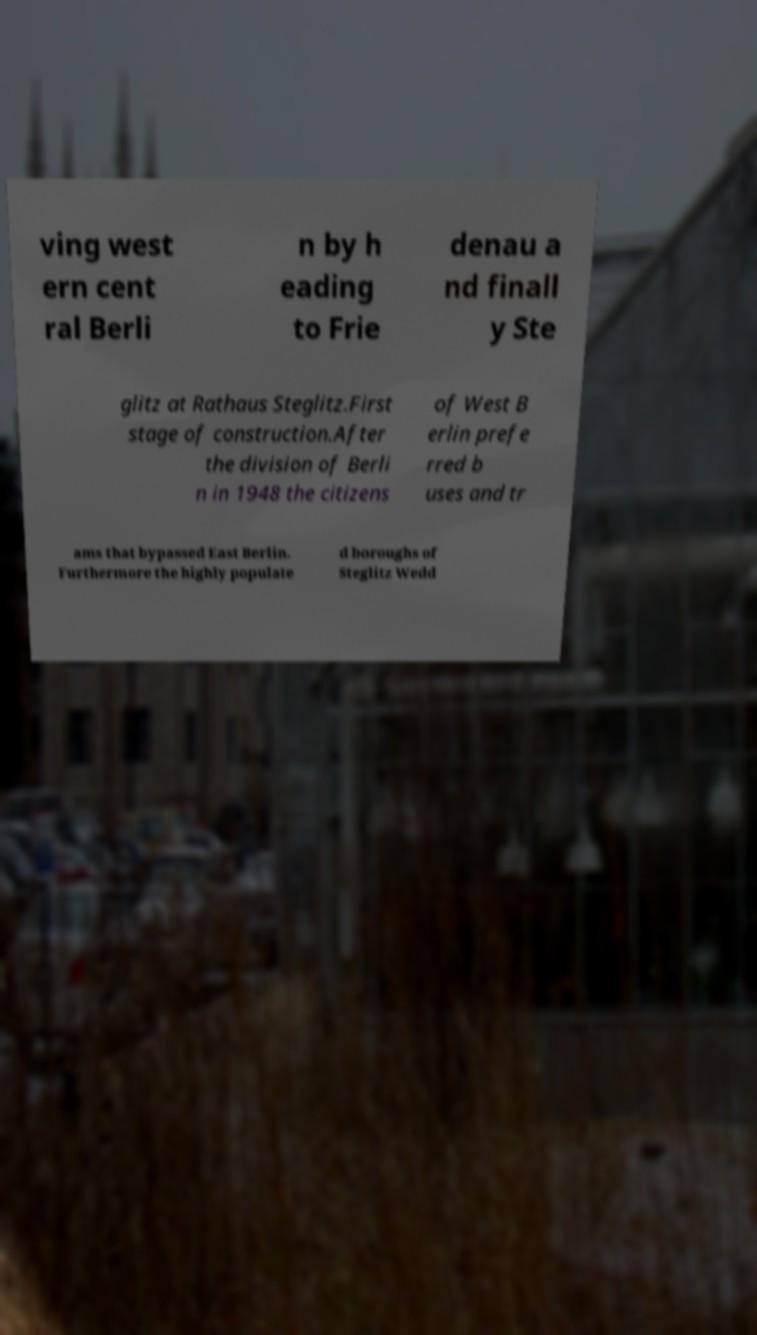There's text embedded in this image that I need extracted. Can you transcribe it verbatim? ving west ern cent ral Berli n by h eading to Frie denau a nd finall y Ste glitz at Rathaus Steglitz.First stage of construction.After the division of Berli n in 1948 the citizens of West B erlin prefe rred b uses and tr ams that bypassed East Berlin. Furthermore the highly populate d boroughs of Steglitz Wedd 